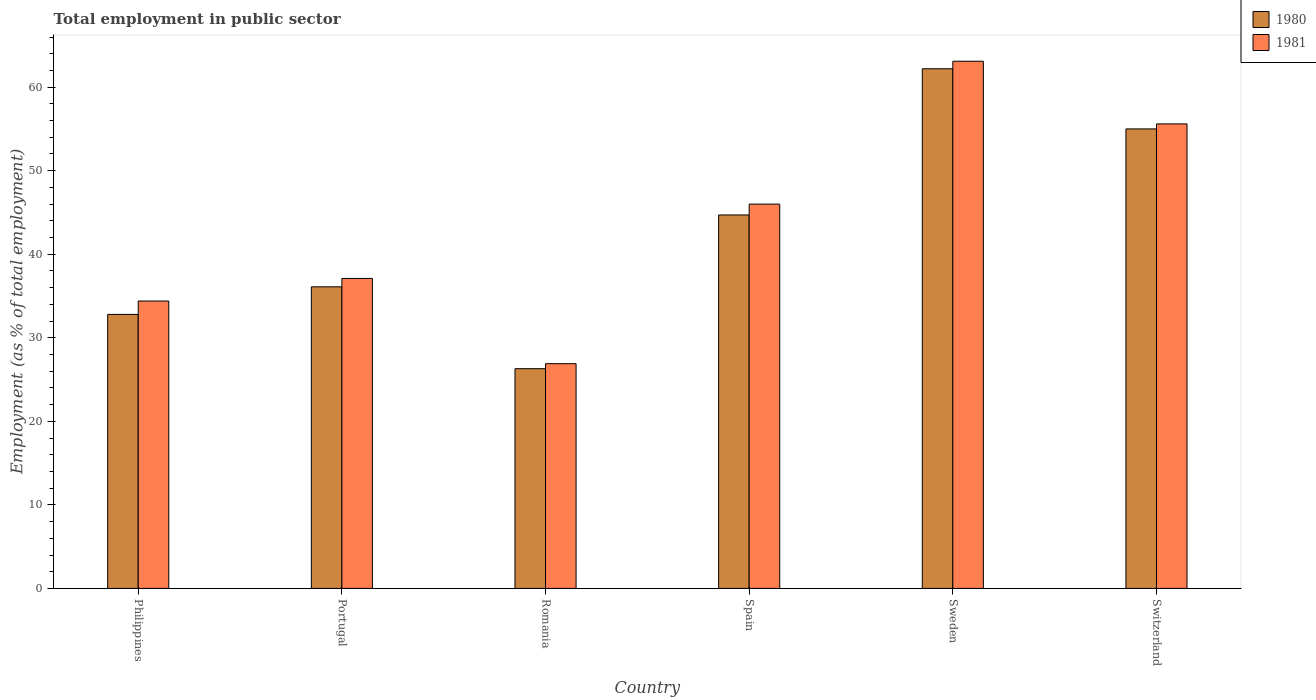Are the number of bars per tick equal to the number of legend labels?
Make the answer very short. Yes. How many bars are there on the 2nd tick from the left?
Your response must be concise. 2. What is the label of the 3rd group of bars from the left?
Your answer should be compact. Romania. What is the employment in public sector in 1981 in Sweden?
Ensure brevity in your answer.  63.1. Across all countries, what is the maximum employment in public sector in 1981?
Make the answer very short. 63.1. Across all countries, what is the minimum employment in public sector in 1981?
Keep it short and to the point. 26.9. In which country was the employment in public sector in 1980 minimum?
Make the answer very short. Romania. What is the total employment in public sector in 1980 in the graph?
Provide a succinct answer. 257.1. What is the difference between the employment in public sector in 1980 in Portugal and that in Switzerland?
Provide a short and direct response. -18.9. What is the difference between the employment in public sector in 1981 in Switzerland and the employment in public sector in 1980 in Portugal?
Provide a short and direct response. 19.5. What is the average employment in public sector in 1981 per country?
Your answer should be compact. 43.85. What is the difference between the employment in public sector of/in 1980 and employment in public sector of/in 1981 in Romania?
Provide a succinct answer. -0.6. In how many countries, is the employment in public sector in 1980 greater than 38 %?
Offer a terse response. 3. What is the ratio of the employment in public sector in 1981 in Philippines to that in Spain?
Offer a very short reply. 0.75. Is the employment in public sector in 1980 in Philippines less than that in Sweden?
Offer a very short reply. Yes. What is the difference between the highest and the second highest employment in public sector in 1980?
Offer a terse response. -17.5. What is the difference between the highest and the lowest employment in public sector in 1981?
Offer a terse response. 36.2. What does the 1st bar from the right in Sweden represents?
Give a very brief answer. 1981. Does the graph contain grids?
Keep it short and to the point. No. How many legend labels are there?
Your answer should be very brief. 2. How are the legend labels stacked?
Keep it short and to the point. Vertical. What is the title of the graph?
Ensure brevity in your answer.  Total employment in public sector. What is the label or title of the Y-axis?
Provide a short and direct response. Employment (as % of total employment). What is the Employment (as % of total employment) of 1980 in Philippines?
Provide a short and direct response. 32.8. What is the Employment (as % of total employment) in 1981 in Philippines?
Ensure brevity in your answer.  34.4. What is the Employment (as % of total employment) of 1980 in Portugal?
Your response must be concise. 36.1. What is the Employment (as % of total employment) of 1981 in Portugal?
Provide a succinct answer. 37.1. What is the Employment (as % of total employment) of 1980 in Romania?
Give a very brief answer. 26.3. What is the Employment (as % of total employment) of 1981 in Romania?
Give a very brief answer. 26.9. What is the Employment (as % of total employment) of 1980 in Spain?
Keep it short and to the point. 44.7. What is the Employment (as % of total employment) of 1981 in Spain?
Your answer should be very brief. 46. What is the Employment (as % of total employment) in 1980 in Sweden?
Your answer should be compact. 62.2. What is the Employment (as % of total employment) of 1981 in Sweden?
Keep it short and to the point. 63.1. What is the Employment (as % of total employment) of 1980 in Switzerland?
Give a very brief answer. 55. What is the Employment (as % of total employment) in 1981 in Switzerland?
Offer a very short reply. 55.6. Across all countries, what is the maximum Employment (as % of total employment) in 1980?
Make the answer very short. 62.2. Across all countries, what is the maximum Employment (as % of total employment) in 1981?
Provide a short and direct response. 63.1. Across all countries, what is the minimum Employment (as % of total employment) in 1980?
Your response must be concise. 26.3. Across all countries, what is the minimum Employment (as % of total employment) of 1981?
Your answer should be compact. 26.9. What is the total Employment (as % of total employment) in 1980 in the graph?
Keep it short and to the point. 257.1. What is the total Employment (as % of total employment) in 1981 in the graph?
Provide a short and direct response. 263.1. What is the difference between the Employment (as % of total employment) of 1981 in Philippines and that in Portugal?
Keep it short and to the point. -2.7. What is the difference between the Employment (as % of total employment) of 1981 in Philippines and that in Spain?
Give a very brief answer. -11.6. What is the difference between the Employment (as % of total employment) in 1980 in Philippines and that in Sweden?
Offer a very short reply. -29.4. What is the difference between the Employment (as % of total employment) in 1981 in Philippines and that in Sweden?
Offer a very short reply. -28.7. What is the difference between the Employment (as % of total employment) in 1980 in Philippines and that in Switzerland?
Provide a short and direct response. -22.2. What is the difference between the Employment (as % of total employment) of 1981 in Philippines and that in Switzerland?
Ensure brevity in your answer.  -21.2. What is the difference between the Employment (as % of total employment) in 1980 in Portugal and that in Spain?
Offer a terse response. -8.6. What is the difference between the Employment (as % of total employment) in 1981 in Portugal and that in Spain?
Your answer should be very brief. -8.9. What is the difference between the Employment (as % of total employment) of 1980 in Portugal and that in Sweden?
Offer a very short reply. -26.1. What is the difference between the Employment (as % of total employment) in 1981 in Portugal and that in Sweden?
Provide a short and direct response. -26. What is the difference between the Employment (as % of total employment) in 1980 in Portugal and that in Switzerland?
Make the answer very short. -18.9. What is the difference between the Employment (as % of total employment) in 1981 in Portugal and that in Switzerland?
Your answer should be compact. -18.5. What is the difference between the Employment (as % of total employment) in 1980 in Romania and that in Spain?
Your answer should be very brief. -18.4. What is the difference between the Employment (as % of total employment) of 1981 in Romania and that in Spain?
Keep it short and to the point. -19.1. What is the difference between the Employment (as % of total employment) in 1980 in Romania and that in Sweden?
Ensure brevity in your answer.  -35.9. What is the difference between the Employment (as % of total employment) in 1981 in Romania and that in Sweden?
Make the answer very short. -36.2. What is the difference between the Employment (as % of total employment) of 1980 in Romania and that in Switzerland?
Your response must be concise. -28.7. What is the difference between the Employment (as % of total employment) of 1981 in Romania and that in Switzerland?
Offer a terse response. -28.7. What is the difference between the Employment (as % of total employment) in 1980 in Spain and that in Sweden?
Give a very brief answer. -17.5. What is the difference between the Employment (as % of total employment) of 1981 in Spain and that in Sweden?
Make the answer very short. -17.1. What is the difference between the Employment (as % of total employment) in 1980 in Spain and that in Switzerland?
Your response must be concise. -10.3. What is the difference between the Employment (as % of total employment) of 1981 in Spain and that in Switzerland?
Offer a very short reply. -9.6. What is the difference between the Employment (as % of total employment) of 1980 in Philippines and the Employment (as % of total employment) of 1981 in Portugal?
Offer a very short reply. -4.3. What is the difference between the Employment (as % of total employment) in 1980 in Philippines and the Employment (as % of total employment) in 1981 in Romania?
Provide a succinct answer. 5.9. What is the difference between the Employment (as % of total employment) in 1980 in Philippines and the Employment (as % of total employment) in 1981 in Spain?
Keep it short and to the point. -13.2. What is the difference between the Employment (as % of total employment) of 1980 in Philippines and the Employment (as % of total employment) of 1981 in Sweden?
Offer a very short reply. -30.3. What is the difference between the Employment (as % of total employment) of 1980 in Philippines and the Employment (as % of total employment) of 1981 in Switzerland?
Your response must be concise. -22.8. What is the difference between the Employment (as % of total employment) in 1980 in Portugal and the Employment (as % of total employment) in 1981 in Spain?
Your answer should be very brief. -9.9. What is the difference between the Employment (as % of total employment) of 1980 in Portugal and the Employment (as % of total employment) of 1981 in Switzerland?
Keep it short and to the point. -19.5. What is the difference between the Employment (as % of total employment) of 1980 in Romania and the Employment (as % of total employment) of 1981 in Spain?
Ensure brevity in your answer.  -19.7. What is the difference between the Employment (as % of total employment) in 1980 in Romania and the Employment (as % of total employment) in 1981 in Sweden?
Ensure brevity in your answer.  -36.8. What is the difference between the Employment (as % of total employment) in 1980 in Romania and the Employment (as % of total employment) in 1981 in Switzerland?
Give a very brief answer. -29.3. What is the difference between the Employment (as % of total employment) of 1980 in Spain and the Employment (as % of total employment) of 1981 in Sweden?
Keep it short and to the point. -18.4. What is the difference between the Employment (as % of total employment) in 1980 in Sweden and the Employment (as % of total employment) in 1981 in Switzerland?
Your answer should be compact. 6.6. What is the average Employment (as % of total employment) of 1980 per country?
Offer a very short reply. 42.85. What is the average Employment (as % of total employment) of 1981 per country?
Offer a very short reply. 43.85. What is the difference between the Employment (as % of total employment) of 1980 and Employment (as % of total employment) of 1981 in Philippines?
Your answer should be compact. -1.6. What is the difference between the Employment (as % of total employment) of 1980 and Employment (as % of total employment) of 1981 in Portugal?
Make the answer very short. -1. What is the difference between the Employment (as % of total employment) of 1980 and Employment (as % of total employment) of 1981 in Spain?
Offer a very short reply. -1.3. What is the difference between the Employment (as % of total employment) of 1980 and Employment (as % of total employment) of 1981 in Sweden?
Ensure brevity in your answer.  -0.9. What is the ratio of the Employment (as % of total employment) of 1980 in Philippines to that in Portugal?
Offer a terse response. 0.91. What is the ratio of the Employment (as % of total employment) of 1981 in Philippines to that in Portugal?
Ensure brevity in your answer.  0.93. What is the ratio of the Employment (as % of total employment) of 1980 in Philippines to that in Romania?
Offer a very short reply. 1.25. What is the ratio of the Employment (as % of total employment) in 1981 in Philippines to that in Romania?
Keep it short and to the point. 1.28. What is the ratio of the Employment (as % of total employment) of 1980 in Philippines to that in Spain?
Ensure brevity in your answer.  0.73. What is the ratio of the Employment (as % of total employment) of 1981 in Philippines to that in Spain?
Your response must be concise. 0.75. What is the ratio of the Employment (as % of total employment) of 1980 in Philippines to that in Sweden?
Offer a very short reply. 0.53. What is the ratio of the Employment (as % of total employment) of 1981 in Philippines to that in Sweden?
Your answer should be very brief. 0.55. What is the ratio of the Employment (as % of total employment) in 1980 in Philippines to that in Switzerland?
Make the answer very short. 0.6. What is the ratio of the Employment (as % of total employment) in 1981 in Philippines to that in Switzerland?
Ensure brevity in your answer.  0.62. What is the ratio of the Employment (as % of total employment) of 1980 in Portugal to that in Romania?
Keep it short and to the point. 1.37. What is the ratio of the Employment (as % of total employment) of 1981 in Portugal to that in Romania?
Your response must be concise. 1.38. What is the ratio of the Employment (as % of total employment) in 1980 in Portugal to that in Spain?
Provide a short and direct response. 0.81. What is the ratio of the Employment (as % of total employment) of 1981 in Portugal to that in Spain?
Provide a succinct answer. 0.81. What is the ratio of the Employment (as % of total employment) in 1980 in Portugal to that in Sweden?
Give a very brief answer. 0.58. What is the ratio of the Employment (as % of total employment) of 1981 in Portugal to that in Sweden?
Ensure brevity in your answer.  0.59. What is the ratio of the Employment (as % of total employment) of 1980 in Portugal to that in Switzerland?
Your answer should be compact. 0.66. What is the ratio of the Employment (as % of total employment) of 1981 in Portugal to that in Switzerland?
Your answer should be compact. 0.67. What is the ratio of the Employment (as % of total employment) of 1980 in Romania to that in Spain?
Provide a short and direct response. 0.59. What is the ratio of the Employment (as % of total employment) in 1981 in Romania to that in Spain?
Your answer should be very brief. 0.58. What is the ratio of the Employment (as % of total employment) in 1980 in Romania to that in Sweden?
Make the answer very short. 0.42. What is the ratio of the Employment (as % of total employment) in 1981 in Romania to that in Sweden?
Keep it short and to the point. 0.43. What is the ratio of the Employment (as % of total employment) in 1980 in Romania to that in Switzerland?
Your answer should be compact. 0.48. What is the ratio of the Employment (as % of total employment) of 1981 in Romania to that in Switzerland?
Your answer should be compact. 0.48. What is the ratio of the Employment (as % of total employment) in 1980 in Spain to that in Sweden?
Your response must be concise. 0.72. What is the ratio of the Employment (as % of total employment) in 1981 in Spain to that in Sweden?
Offer a very short reply. 0.73. What is the ratio of the Employment (as % of total employment) of 1980 in Spain to that in Switzerland?
Provide a short and direct response. 0.81. What is the ratio of the Employment (as % of total employment) of 1981 in Spain to that in Switzerland?
Provide a short and direct response. 0.83. What is the ratio of the Employment (as % of total employment) of 1980 in Sweden to that in Switzerland?
Ensure brevity in your answer.  1.13. What is the ratio of the Employment (as % of total employment) in 1981 in Sweden to that in Switzerland?
Your answer should be very brief. 1.13. What is the difference between the highest and the second highest Employment (as % of total employment) of 1981?
Offer a terse response. 7.5. What is the difference between the highest and the lowest Employment (as % of total employment) in 1980?
Your response must be concise. 35.9. What is the difference between the highest and the lowest Employment (as % of total employment) in 1981?
Provide a short and direct response. 36.2. 